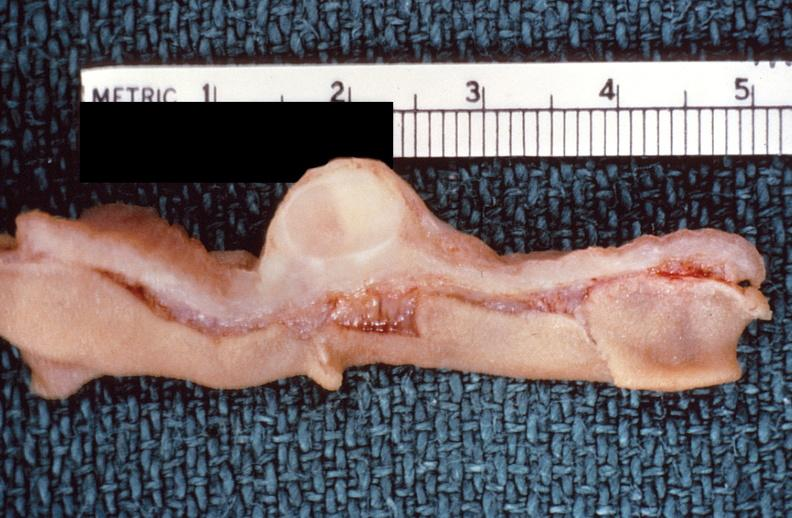what does this image show?
Answer the question using a single word or phrase. Intestine 